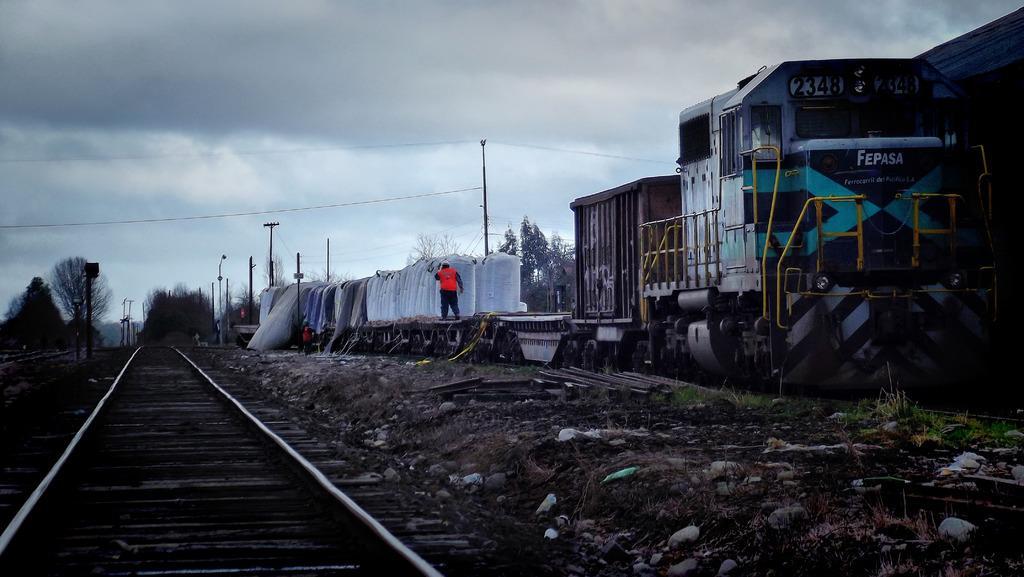How would you summarize this image in a sentence or two? In this image there is a train on the railway track. There is a person standing on the train. There are containers on the train. To the left there is a railway track. There are stones and grass on the ground. In the background there are trees and poles. At the top there is the sky. 